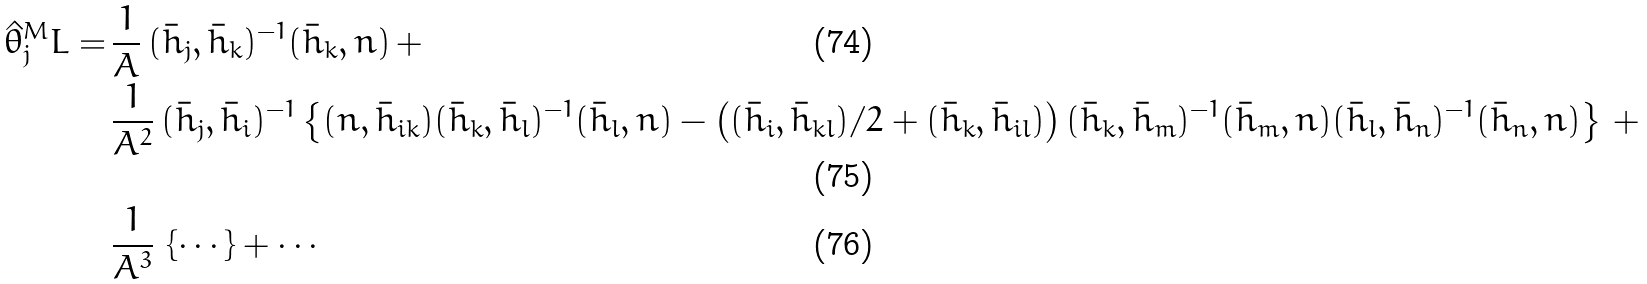<formula> <loc_0><loc_0><loc_500><loc_500>\hat { \theta } _ { j } ^ { M } L = \, & \frac { 1 } { A } \, ( \bar { h } _ { j } , \bar { h } _ { k } ) ^ { - 1 } ( \bar { h } _ { k } , n ) \, + \\ & \frac { 1 } { A ^ { 2 } } \, ( \bar { h } _ { j } , \bar { h } _ { i } ) ^ { - 1 } \left \{ ( n , \bar { h } _ { i k } ) ( \bar { h } _ { k } , \bar { h } _ { l } ) ^ { - 1 } ( \bar { h } _ { l } , n ) - \left ( ( \bar { h } _ { i } , \bar { h } _ { k l } ) / 2 + ( \bar { h } _ { k } , \bar { h } _ { i l } ) \right ) ( \bar { h } _ { k } , \bar { h } _ { m } ) ^ { - 1 } ( \bar { h } _ { m } , n ) ( \bar { h } _ { l } , \bar { h } _ { n } ) ^ { - 1 } ( \bar { h } _ { n } , n ) \right \} \, + \\ & \frac { 1 } { A ^ { 3 } } \, \left \{ \cdots \right \} + \cdots</formula> 